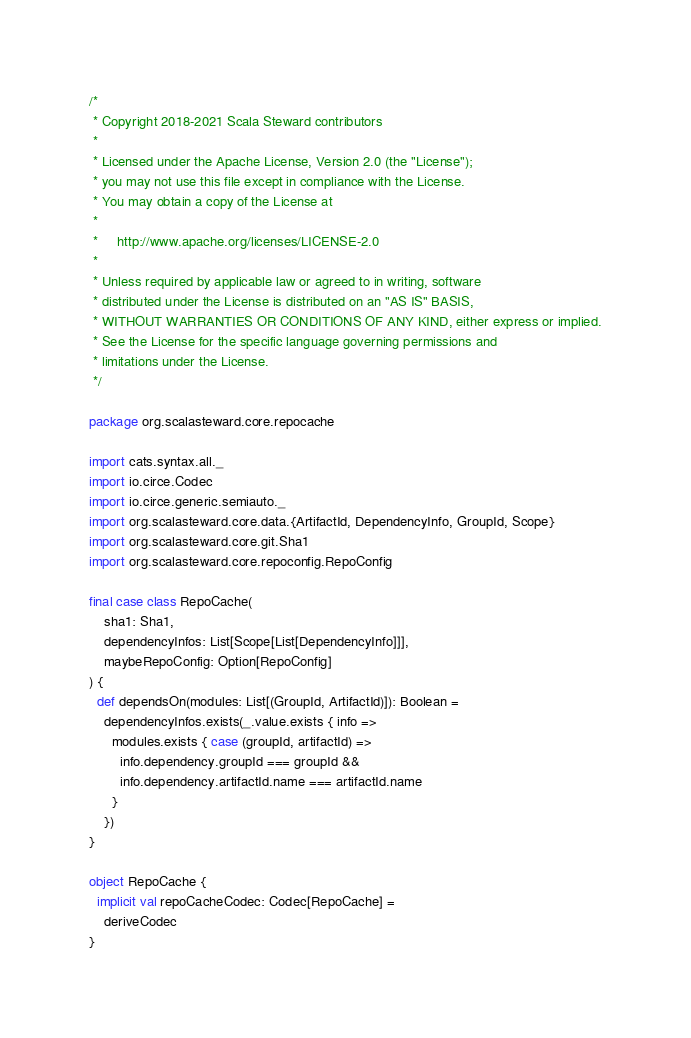<code> <loc_0><loc_0><loc_500><loc_500><_Scala_>/*
 * Copyright 2018-2021 Scala Steward contributors
 *
 * Licensed under the Apache License, Version 2.0 (the "License");
 * you may not use this file except in compliance with the License.
 * You may obtain a copy of the License at
 *
 *     http://www.apache.org/licenses/LICENSE-2.0
 *
 * Unless required by applicable law or agreed to in writing, software
 * distributed under the License is distributed on an "AS IS" BASIS,
 * WITHOUT WARRANTIES OR CONDITIONS OF ANY KIND, either express or implied.
 * See the License for the specific language governing permissions and
 * limitations under the License.
 */

package org.scalasteward.core.repocache

import cats.syntax.all._
import io.circe.Codec
import io.circe.generic.semiauto._
import org.scalasteward.core.data.{ArtifactId, DependencyInfo, GroupId, Scope}
import org.scalasteward.core.git.Sha1
import org.scalasteward.core.repoconfig.RepoConfig

final case class RepoCache(
    sha1: Sha1,
    dependencyInfos: List[Scope[List[DependencyInfo]]],
    maybeRepoConfig: Option[RepoConfig]
) {
  def dependsOn(modules: List[(GroupId, ArtifactId)]): Boolean =
    dependencyInfos.exists(_.value.exists { info =>
      modules.exists { case (groupId, artifactId) =>
        info.dependency.groupId === groupId &&
        info.dependency.artifactId.name === artifactId.name
      }
    })
}

object RepoCache {
  implicit val repoCacheCodec: Codec[RepoCache] =
    deriveCodec
}
</code> 